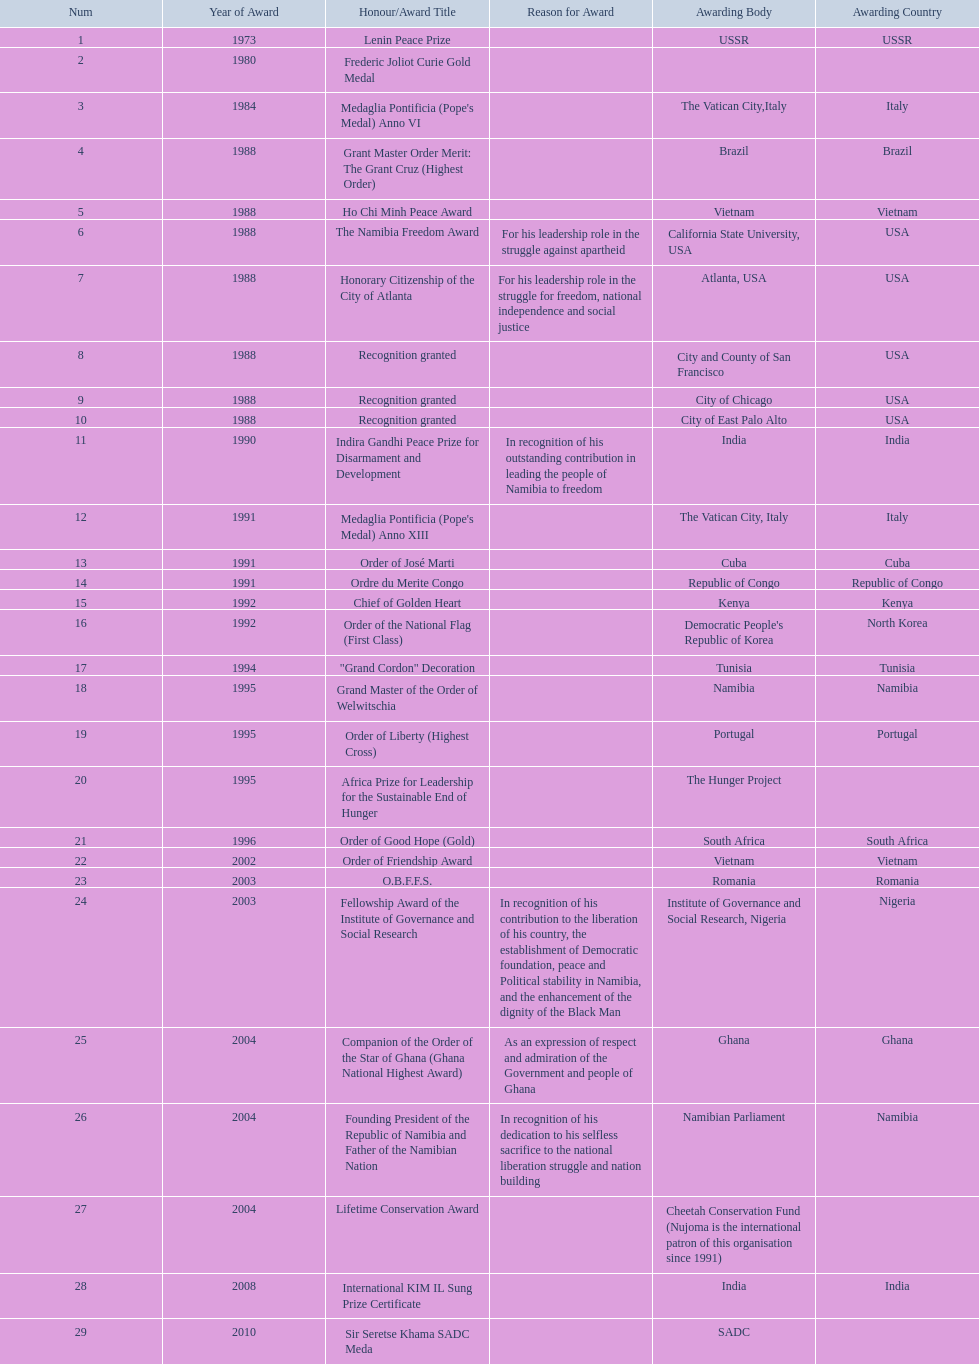Which awarding bodies have recognized sam nujoma? USSR, , The Vatican City,Italy, Brazil, Vietnam, California State University, USA, Atlanta, USA, City and County of San Francisco, City of Chicago, City of East Palo Alto, India, The Vatican City, Italy, Cuba, Republic of Congo, Kenya, Democratic People's Republic of Korea, Tunisia, Namibia, Portugal, The Hunger Project, South Africa, Vietnam, Romania, Institute of Governance and Social Research, Nigeria, Ghana, Namibian Parliament, Cheetah Conservation Fund (Nujoma is the international patron of this organisation since 1991), India, SADC. And what was the title of each award or honour? Lenin Peace Prize, Frederic Joliot Curie Gold Medal, Medaglia Pontificia (Pope's Medal) Anno VI, Grant Master Order Merit: The Grant Cruz (Highest Order), Ho Chi Minh Peace Award, The Namibia Freedom Award, Honorary Citizenship of the City of Atlanta, Recognition granted, Recognition granted, Recognition granted, Indira Gandhi Peace Prize for Disarmament and Development, Medaglia Pontificia (Pope's Medal) Anno XIII, Order of José Marti, Ordre du Merite Congo, Chief of Golden Heart, Order of the National Flag (First Class), "Grand Cordon" Decoration, Grand Master of the Order of Welwitschia, Order of Liberty (Highest Cross), Africa Prize for Leadership for the Sustainable End of Hunger, Order of Good Hope (Gold), Order of Friendship Award, O.B.F.F.S., Fellowship Award of the Institute of Governance and Social Research, Companion of the Order of the Star of Ghana (Ghana National Highest Award), Founding President of the Republic of Namibia and Father of the Namibian Nation, Lifetime Conservation Award, International KIM IL Sung Prize Certificate, Sir Seretse Khama SADC Meda. Of those, which nation awarded him the o.b.f.f.s.? Romania. 